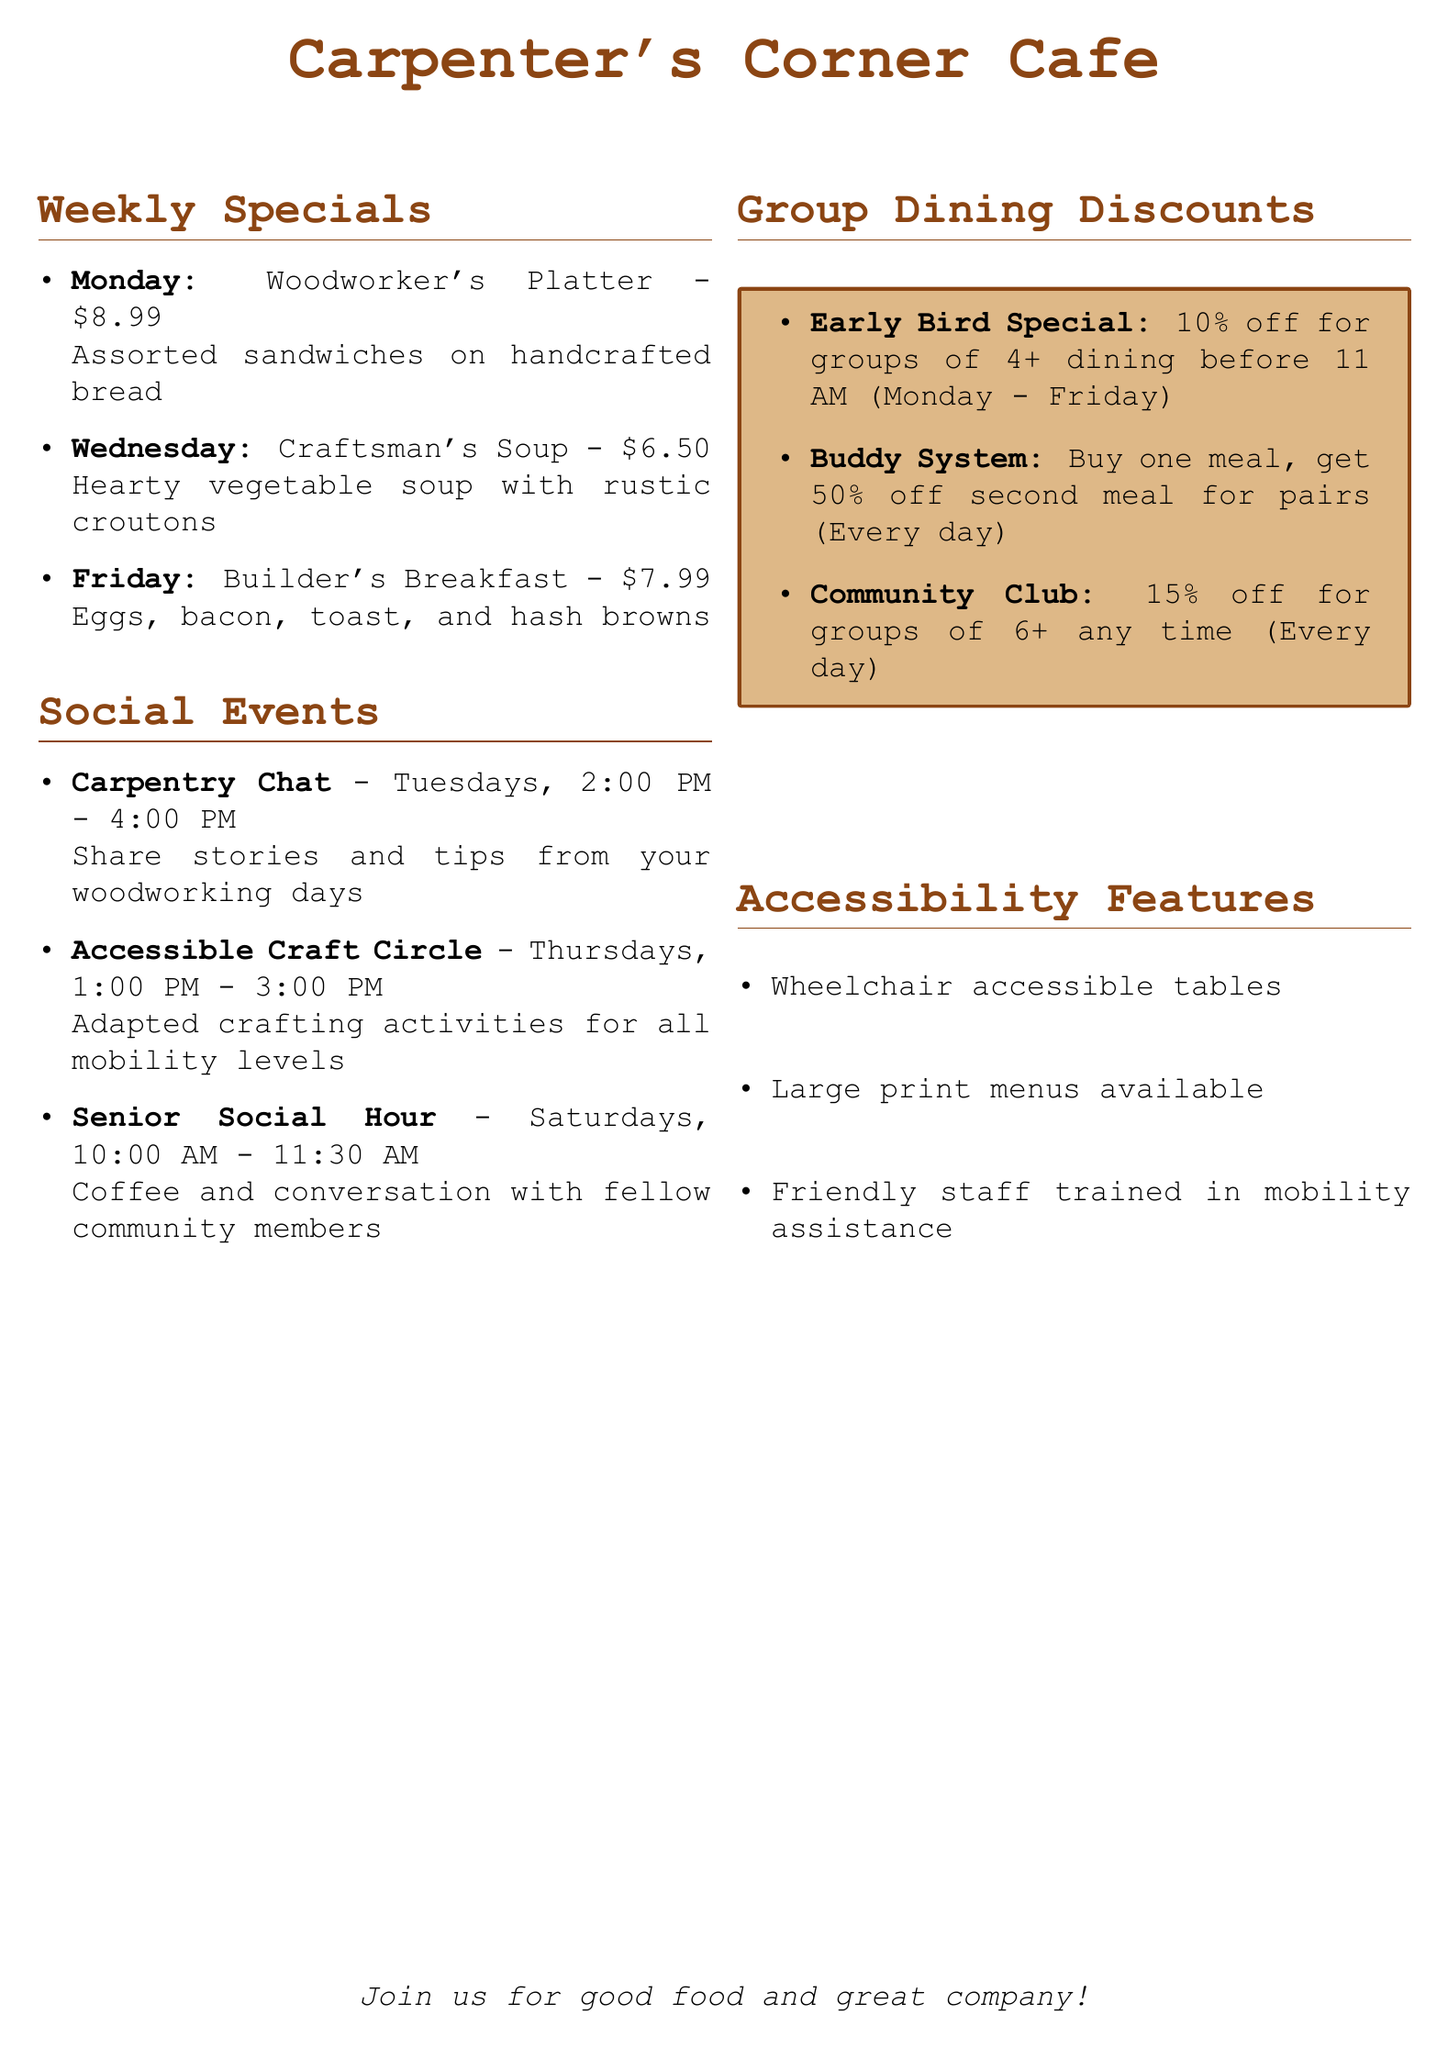What is the name of the cafe? The name of the cafe is highlighted in the document's title section.
Answer: Carpenter's Corner Cafe What is the price of the Woodworker's Platter? The price of the Woodworker's Platter is listed in the weekly specials section.
Answer: $8.99 When does the Accessible Craft Circle take place? The schedule for the Accessible Craft Circle is provided in the social events section.
Answer: Thursdays, 1:00 PM - 3:00 PM How much discount do groups of 6+ receive? The discount for groups of 6+ is mentioned in the group dining discounts section.
Answer: 15% What are the community dining discounts available every day? The discounts available every day are listed in the group dining discounts section.
Answer: Buddy System What time is the Senior Social Hour? The time for the Senior Social Hour is specified in the social events section.
Answer: 10:00 AM - 11:30 AM What is included in the Builder's Breakfast? The contents of the Builder's Breakfast are described in the weekly specials section.
Answer: Eggs, bacon, toast, and hash browns What accessibility feature is mentioned related to staff? The document notes a specific feature regarding the staff's training in accessibility.
Answer: Friendly staff trained in mobility assistance 